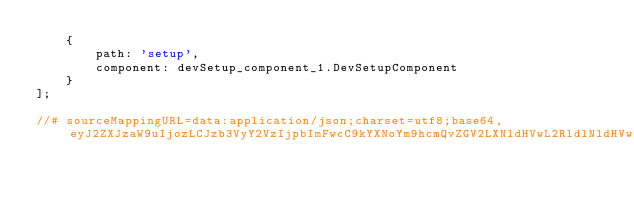Convert code to text. <code><loc_0><loc_0><loc_500><loc_500><_JavaScript_>    {
        path: 'setup',
        component: devSetup_component_1.DevSetupComponent
    }
];

//# sourceMappingURL=data:application/json;charset=utf8;base64,eyJ2ZXJzaW9uIjozLCJzb3VyY2VzIjpbImFwcC9kYXNoYm9hcmQvZGV2LXNldHVwL2RldlNldHVwQ29tcG9uZW50LnJvdXRlcy50cyJdLCJuYW1lcyI6W10sIm1hcHBpbmdzIjoiO0FBQ0EsbUNBQWtDLHNCQUFzQixDQUFDLENBQUE7QUFFNUMsc0JBQWMsR0FBWTtJQUN0QztRQUNDLElBQUksRUFBRSxPQUFPO1FBQ1gsU0FBUyxFQUFFLHNDQUFpQjtLQUM5QjtDQUNELENBQUMiLCJmaWxlIjoiYXBwL2Rhc2hib2FyZC9kZXYtc2V0dXAvZGV2U2V0dXBDb21wb25lbnQucm91dGVzLmpzIiwic291cmNlc0NvbnRlbnQiOlsiaW1wb3J0IHsgUm91dGUgfSBmcm9tICdAYW5ndWxhci9yb3V0ZXInO1xuaW1wb3J0IHsgRGV2U2V0dXBDb21wb25lbnQgfSBmcm9tICcuL2RldlNldHVwLmNvbXBvbmVudCc7XG5cbmV4cG9ydCBjb25zdCBEZXZTZXR1cFJvdXRlczogUm91dGVbXSA9IFtcblx0e1xuXHRcdHBhdGg6ICdzZXR1cCcsXG4gICAgY29tcG9uZW50OiBEZXZTZXR1cENvbXBvbmVudFxuXHR9XG5dO1xuIl19
</code> 